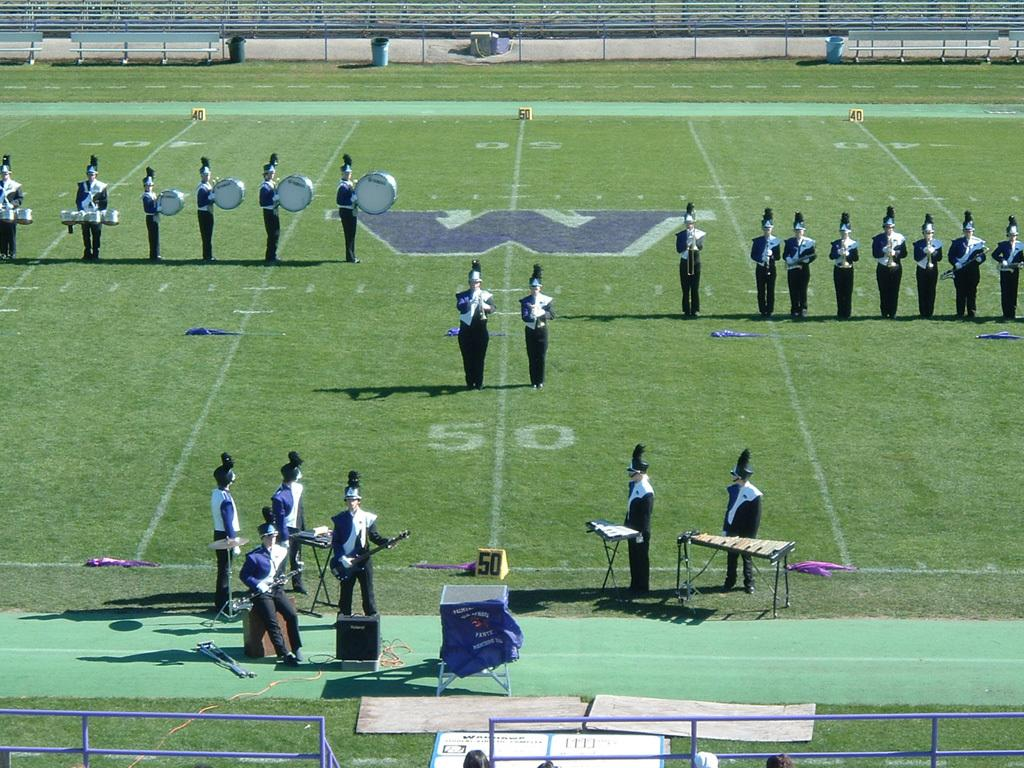How many people are in the image? There is a group of people in the image. What are the people doing in the image? The people are standing and holding musical instruments. What objects can be seen in the image besides the people? There are benches, dustbins, and a speaker in the image. Can you see the secretary's toes in the image? There is no secretary present in the image, and therefore no toes can be seen. 